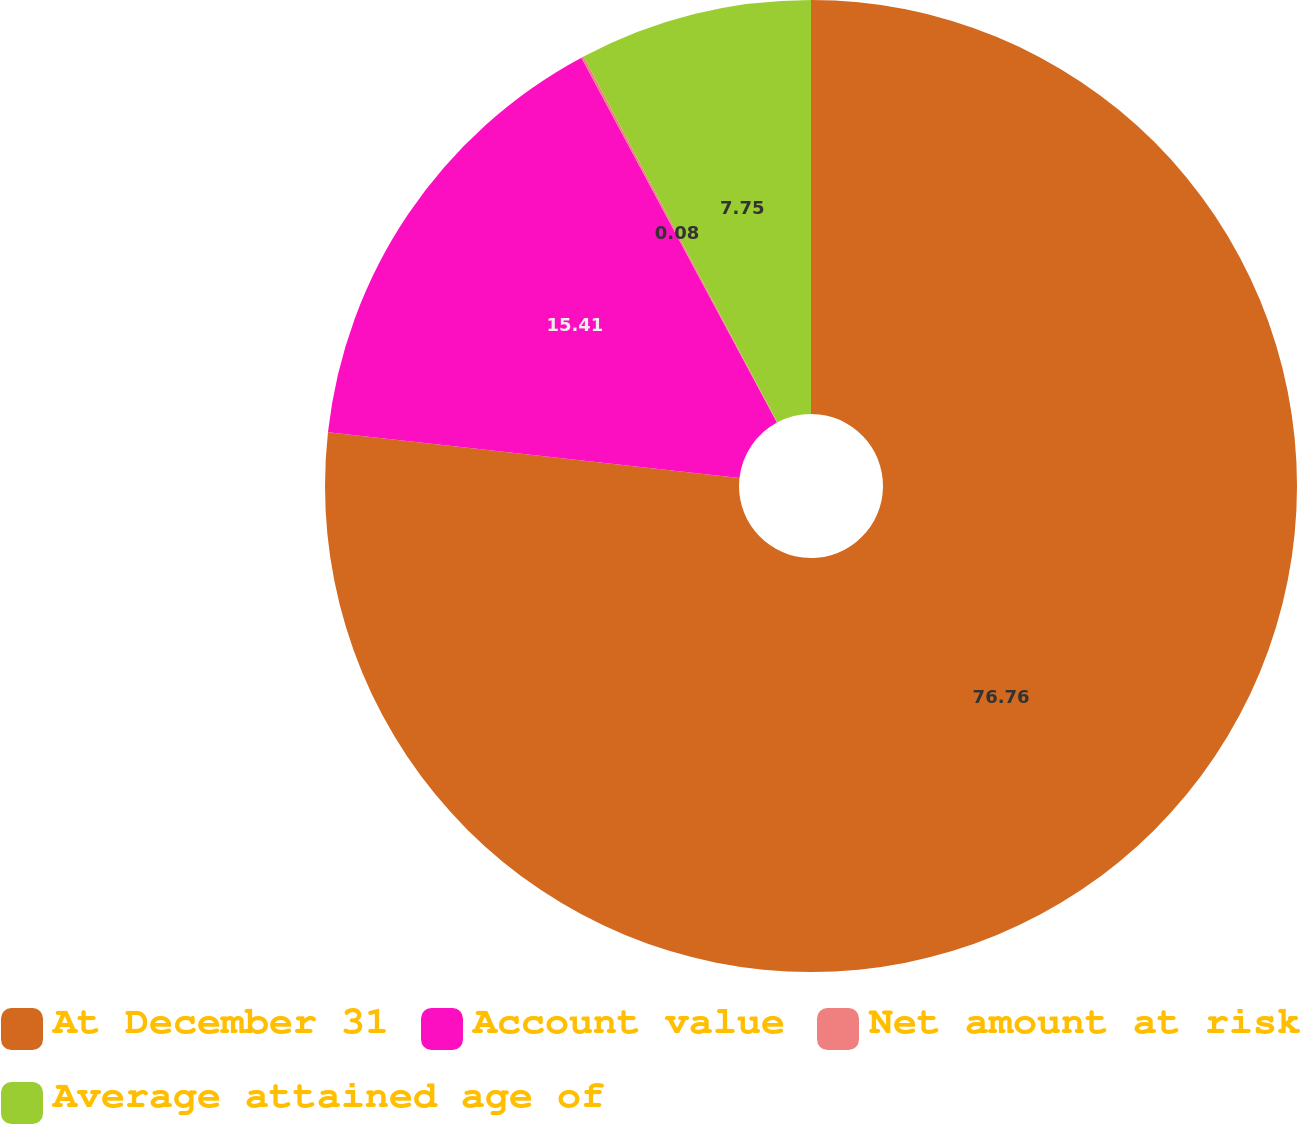Convert chart to OTSL. <chart><loc_0><loc_0><loc_500><loc_500><pie_chart><fcel>At December 31<fcel>Account value<fcel>Net amount at risk<fcel>Average attained age of<nl><fcel>76.76%<fcel>15.41%<fcel>0.08%<fcel>7.75%<nl></chart> 